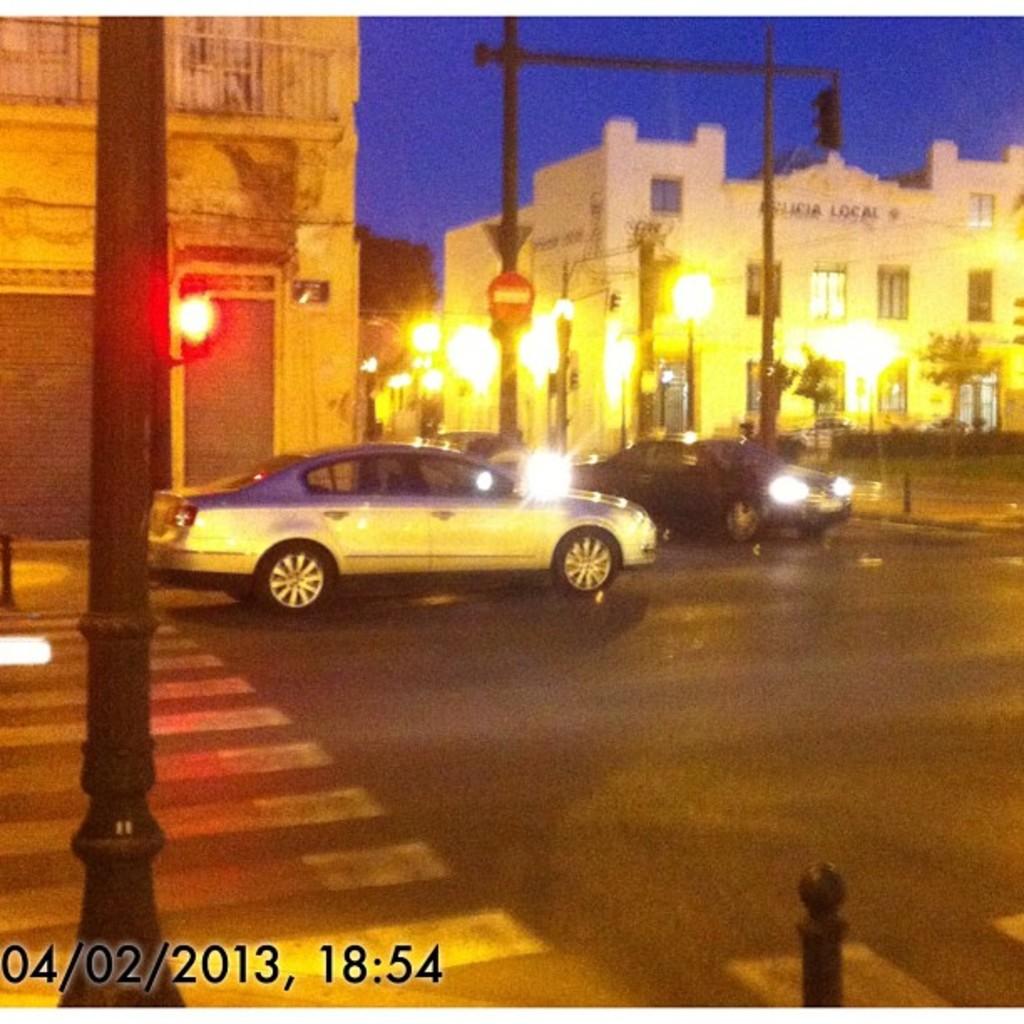What time was this taken?
Your response must be concise. 18:54. What is the date of this photo?
Keep it short and to the point. 04/02/2013. 